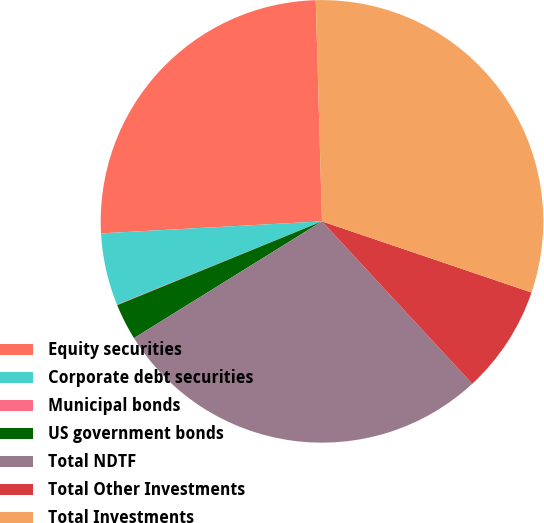Convert chart. <chart><loc_0><loc_0><loc_500><loc_500><pie_chart><fcel>Equity securities<fcel>Corporate debt securities<fcel>Municipal bonds<fcel>US government bonds<fcel>Total NDTF<fcel>Total Other Investments<fcel>Total Investments<nl><fcel>25.42%<fcel>5.28%<fcel>0.04%<fcel>2.66%<fcel>28.04%<fcel>7.91%<fcel>30.66%<nl></chart> 